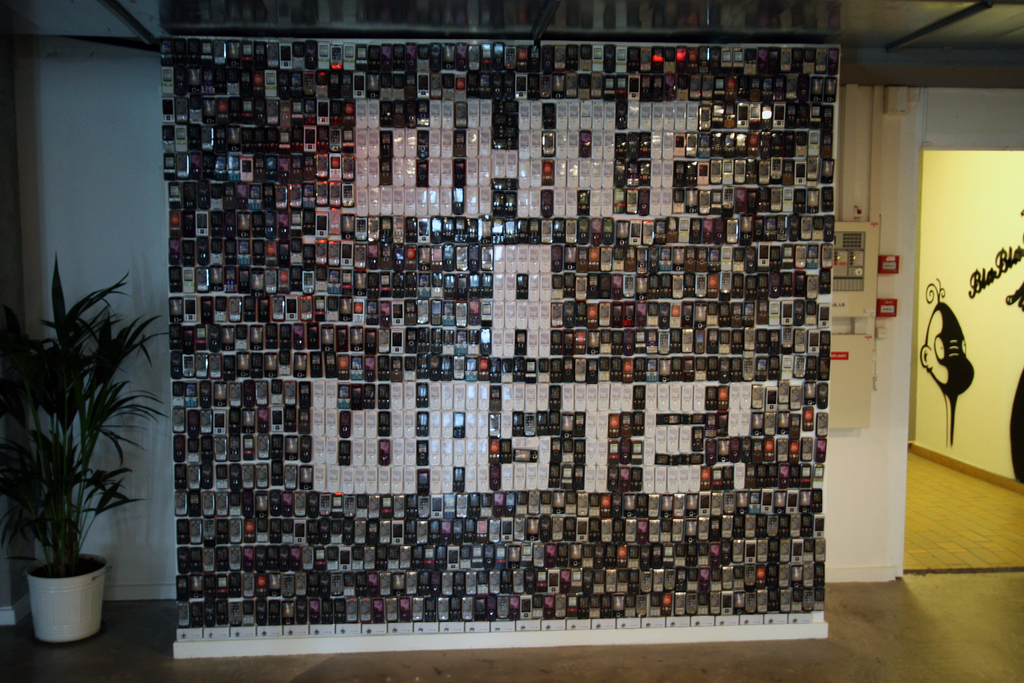Can you speculate on the stories behind the individual photographs used in this installation? Certainly, each photograph in the installation likely bears its own unique narrative. Given the diversity of images, some might be historical snapshots capturing significant events, while others could document everyday moments or personal memories. One could imagine that these photographs include glimpses of different cultures, seminal moments of societal change, or intimate glimpses into people's lives. Together, they span a broad tapestry of human experience, from the banal to the profound. This array of human stories, frozen in time but soaring collectively in the form of a bird, arguably comments on the shared nature of human existence and the common threads that intertwine our individual lives. 